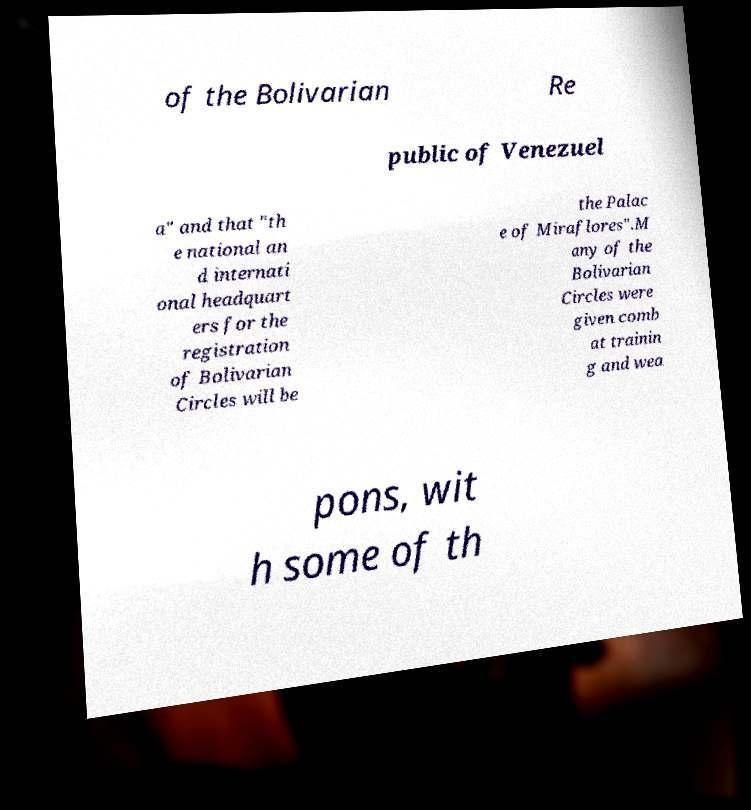For documentation purposes, I need the text within this image transcribed. Could you provide that? of the Bolivarian Re public of Venezuel a" and that "th e national an d internati onal headquart ers for the registration of Bolivarian Circles will be the Palac e of Miraflores".M any of the Bolivarian Circles were given comb at trainin g and wea pons, wit h some of th 